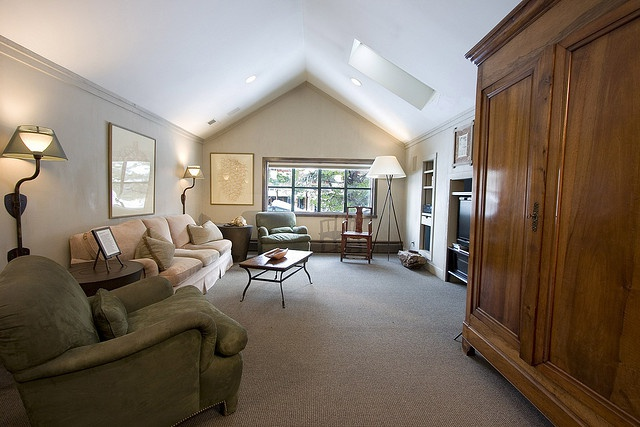Describe the objects in this image and their specific colors. I can see chair in tan, black, and gray tones, couch in tan, darkgray, gray, and maroon tones, chair in tan, gray, black, and darkgray tones, chair in tan, maroon, black, darkgray, and gray tones, and tv in tan, black, and gray tones in this image. 